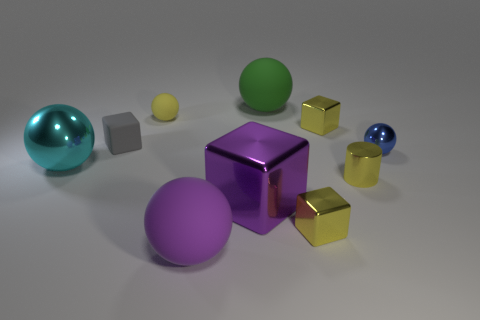Is there anything else of the same color as the metal cylinder?
Offer a terse response. Yes. Is the number of yellow rubber things greater than the number of purple objects?
Your answer should be compact. No. Is the yellow sphere made of the same material as the big purple cube?
Provide a succinct answer. No. How many other yellow cubes have the same material as the large block?
Your response must be concise. 2. Do the yellow cylinder and the yellow shiny cube that is in front of the tiny gray block have the same size?
Give a very brief answer. Yes. There is a big object that is both behind the purple matte sphere and in front of the small yellow cylinder; what is its color?
Offer a terse response. Purple. Is the number of big blue cylinders the same as the number of matte blocks?
Your answer should be very brief. No. Are there any large cyan shiny spheres on the right side of the rubber sphere that is in front of the tiny metallic ball?
Provide a short and direct response. No. Are there an equal number of balls that are behind the large purple block and tiny blocks?
Keep it short and to the point. No. What number of shiny objects are behind the large rubber ball behind the small yellow block that is in front of the blue shiny ball?
Ensure brevity in your answer.  0. 